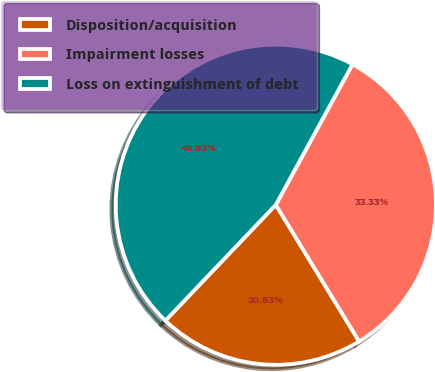Convert chart to OTSL. <chart><loc_0><loc_0><loc_500><loc_500><pie_chart><fcel>Disposition/acquisition<fcel>Impairment losses<fcel>Loss on extinguishment of debt<nl><fcel>20.83%<fcel>33.33%<fcel>45.83%<nl></chart> 